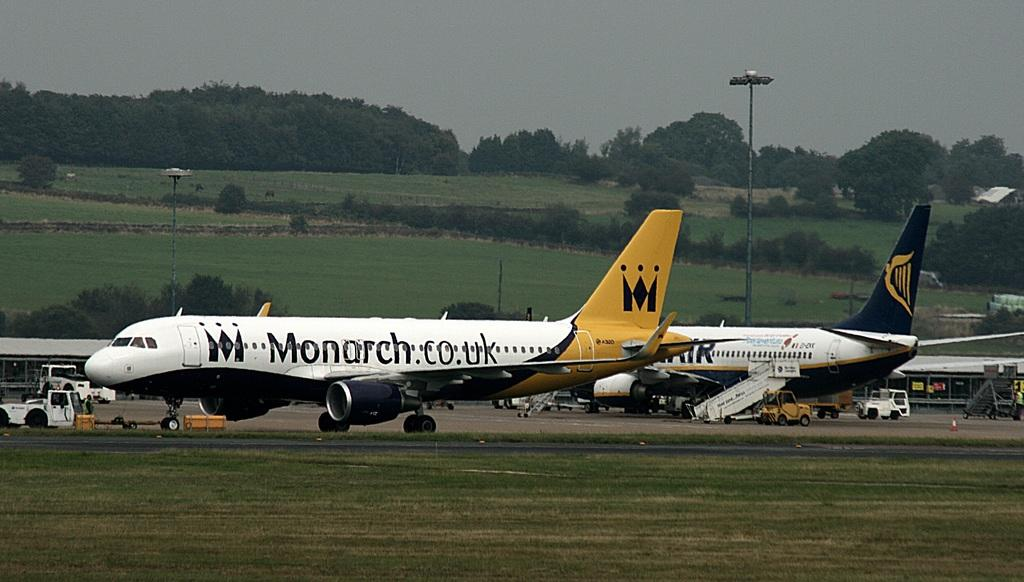Provide a one-sentence caption for the provided image. A plane advertising the website monarch.co.uk with the logo shown. 